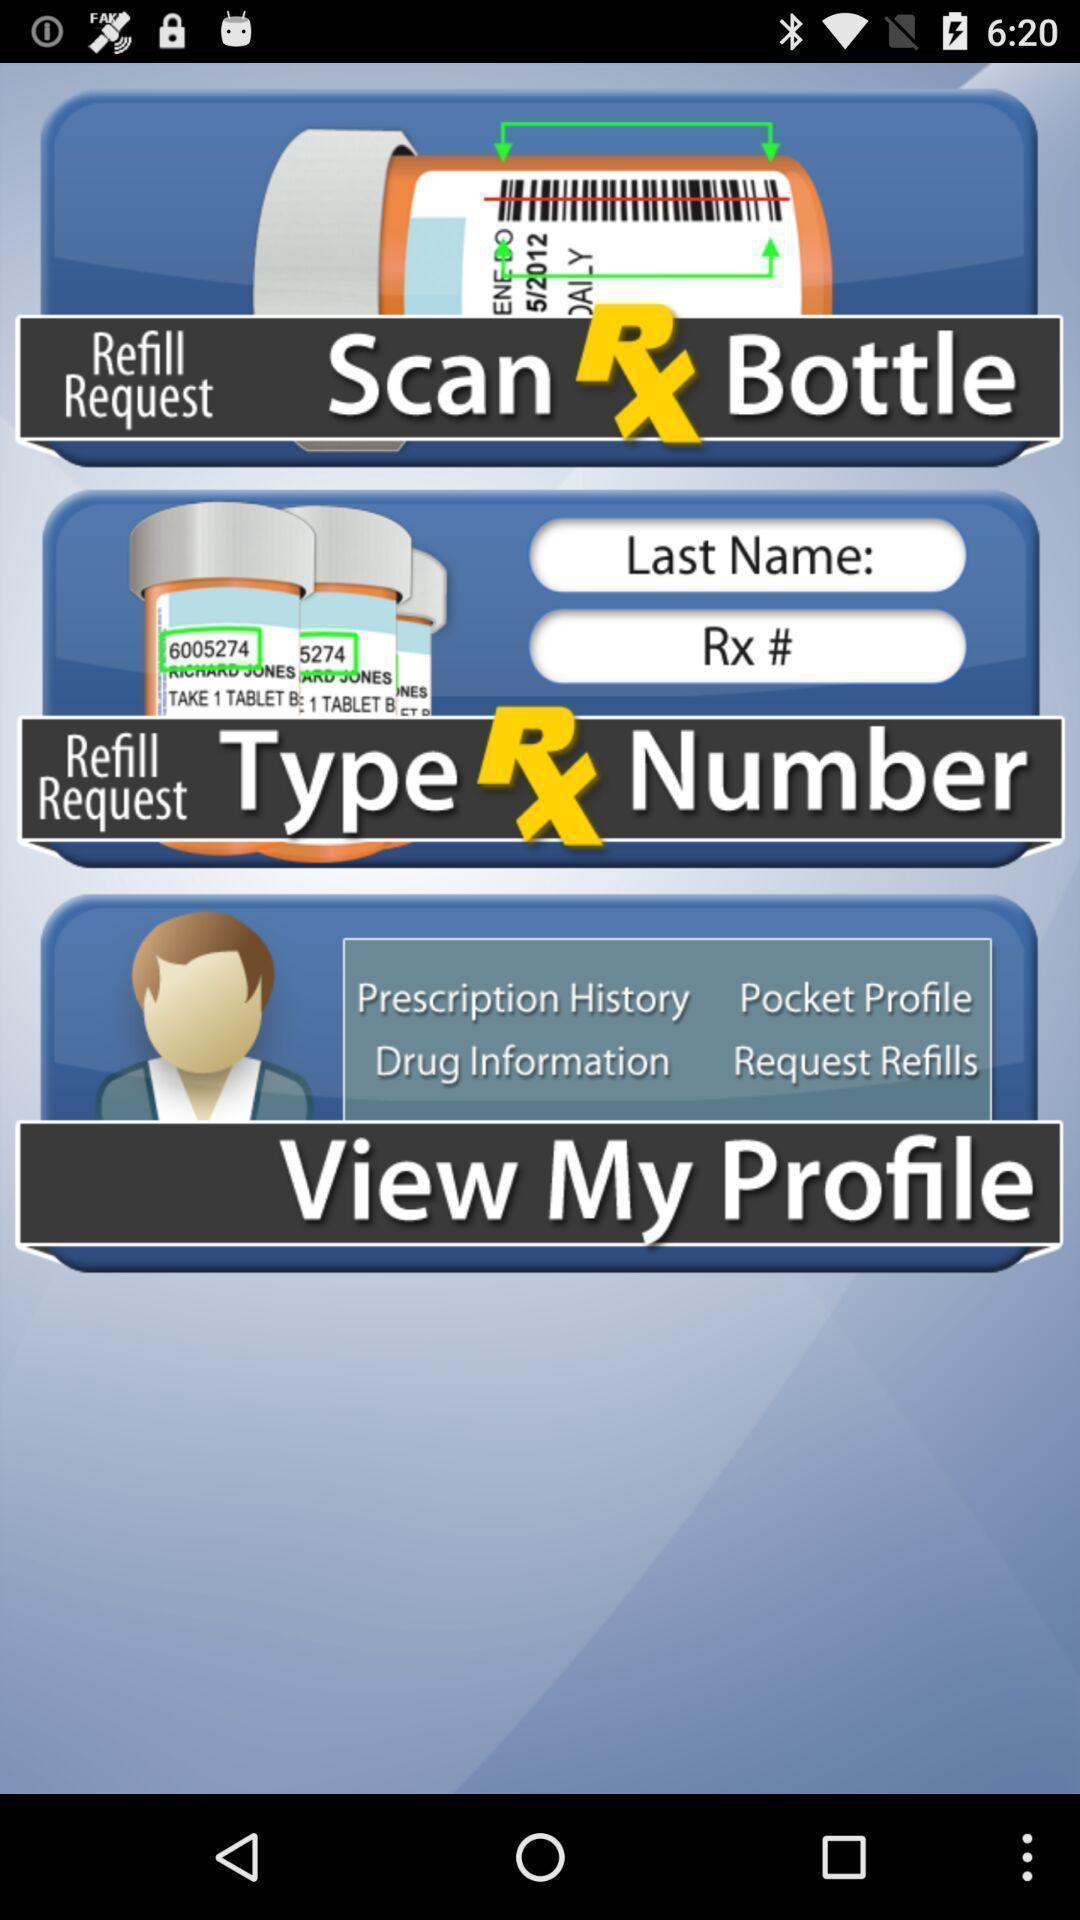Describe this image in words. Screen displaying guide for refill request. 